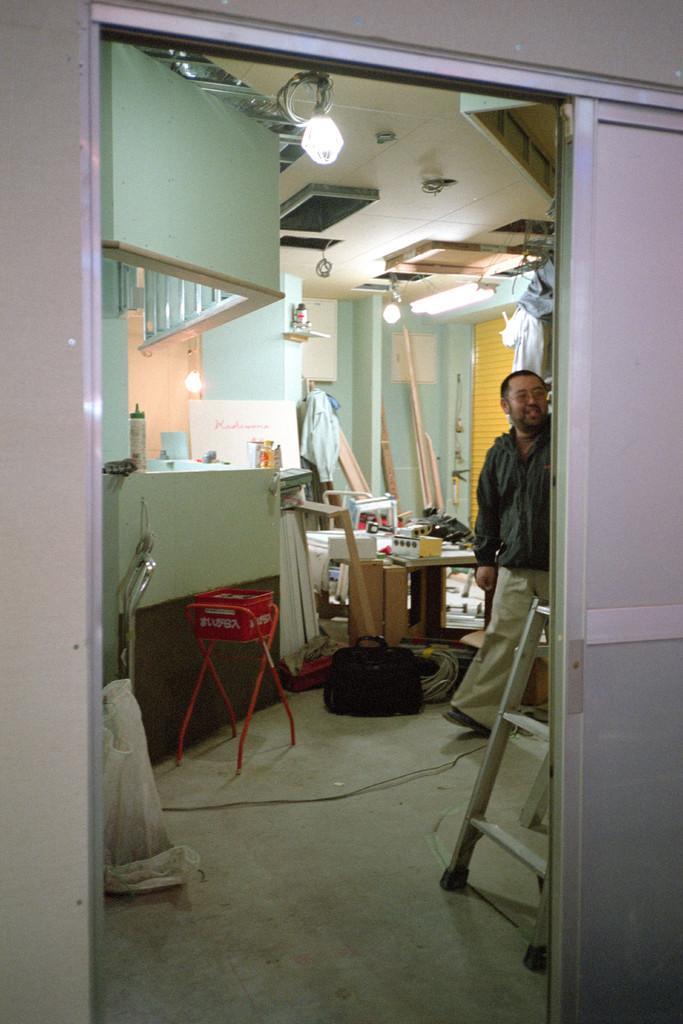In one or two sentences, can you explain what this image depicts? There is a person walking. Near to him there is a ladder. There is a stand with a box on that. In the back there are many items. On the ceiling there are lights. 